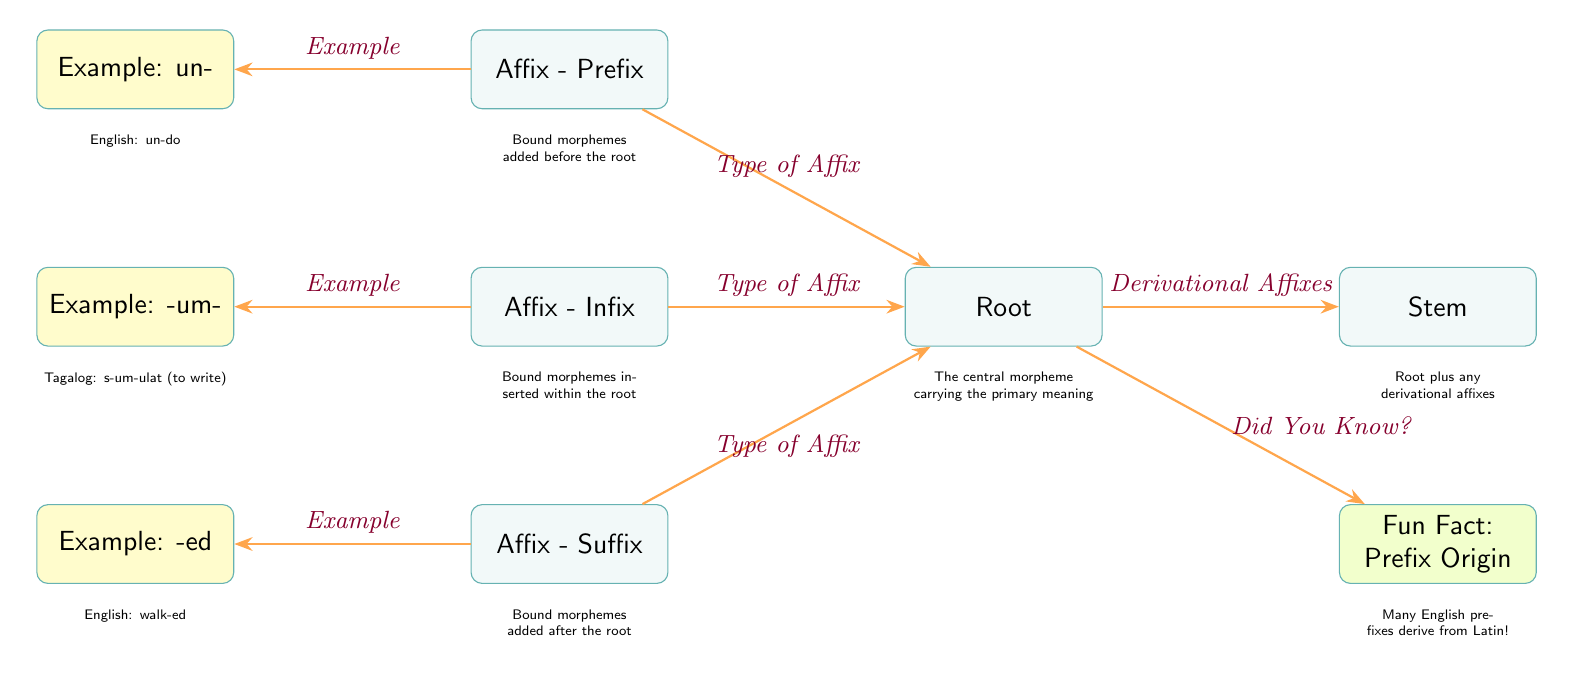What are the three types of affixes shown in the diagram? The diagram lists three types of affixes: Prefix, Infix, and Suffix, which are positioned on the left and below the Root node.
Answer: Prefix, Infix, Suffix What is the example given for the suffix? The example node linked to the Suffix shows "walk-ed," which is located below the Suffix box.
Answer: walk-ed How many affix types are directly linked to the root? The diagram shows three affix types (Prefix, Infix, and Suffix) that are directly connected to the Root, as indicated by the arrows.
Answer: 3 Which language is represented by the infix example? The infix example provided in the diagram is "-um-," which is associated with the Tagalog language as indicated in the descriptive text.
Answer: Tagalog What type of morpheme is the root classified as? The Root is described as the "central morpheme carrying the primary meaning," which can be deduced from the description directly underneath the Root node.
Answer: Central morpheme What does the arrow between the root and stem represent? The arrow that connects the Root to the Stem indicates the relationship of derivational affixes added to the Root to form the Stem, as stated in the diagram.
Answer: Derivational Affixes What is the fun fact related to prefixes? The diagram includes a fun fact node that states "Many English prefixes derive from Latin!" providing additional context to the prefix information.
Answer: Many English prefixes derive from Latin! 